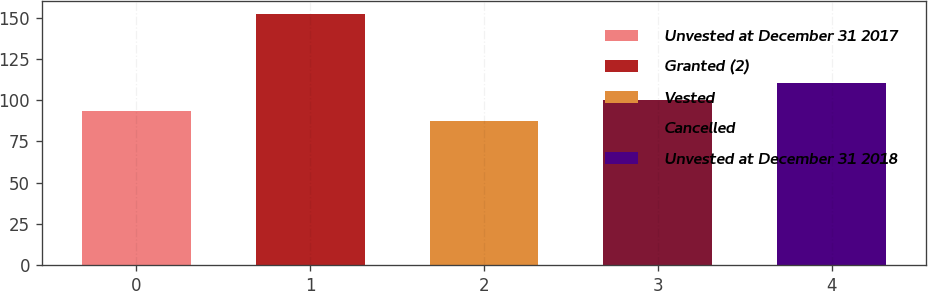Convert chart. <chart><loc_0><loc_0><loc_500><loc_500><bar_chart><fcel>Unvested at December 31 2017<fcel>Granted (2)<fcel>Vested<fcel>Cancelled<fcel>Unvested at December 31 2018<nl><fcel>93.66<fcel>152.4<fcel>87.13<fcel>100.19<fcel>110.5<nl></chart> 